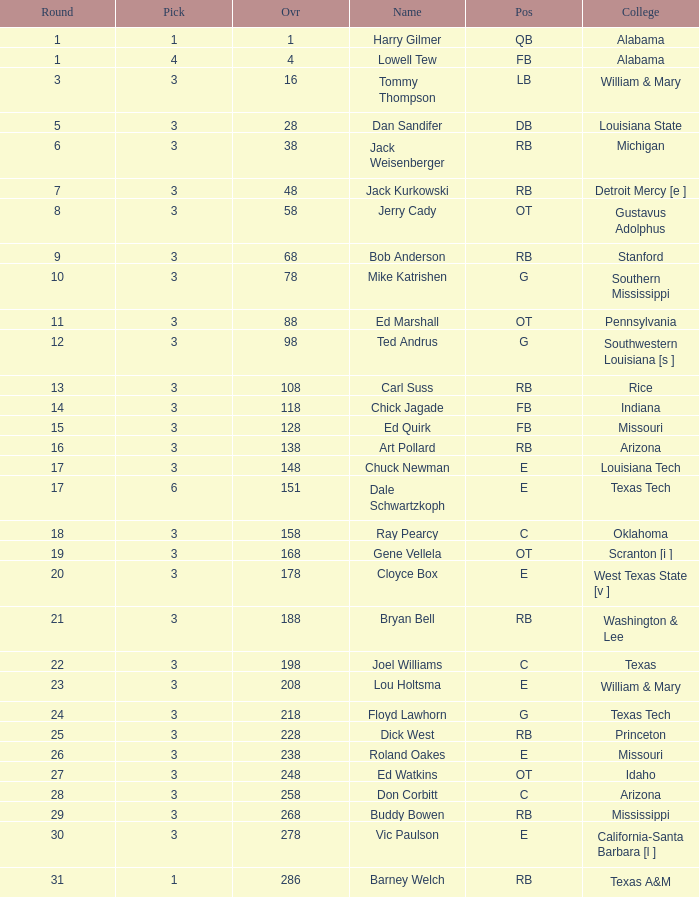What is stanford's average overall? 68.0. 